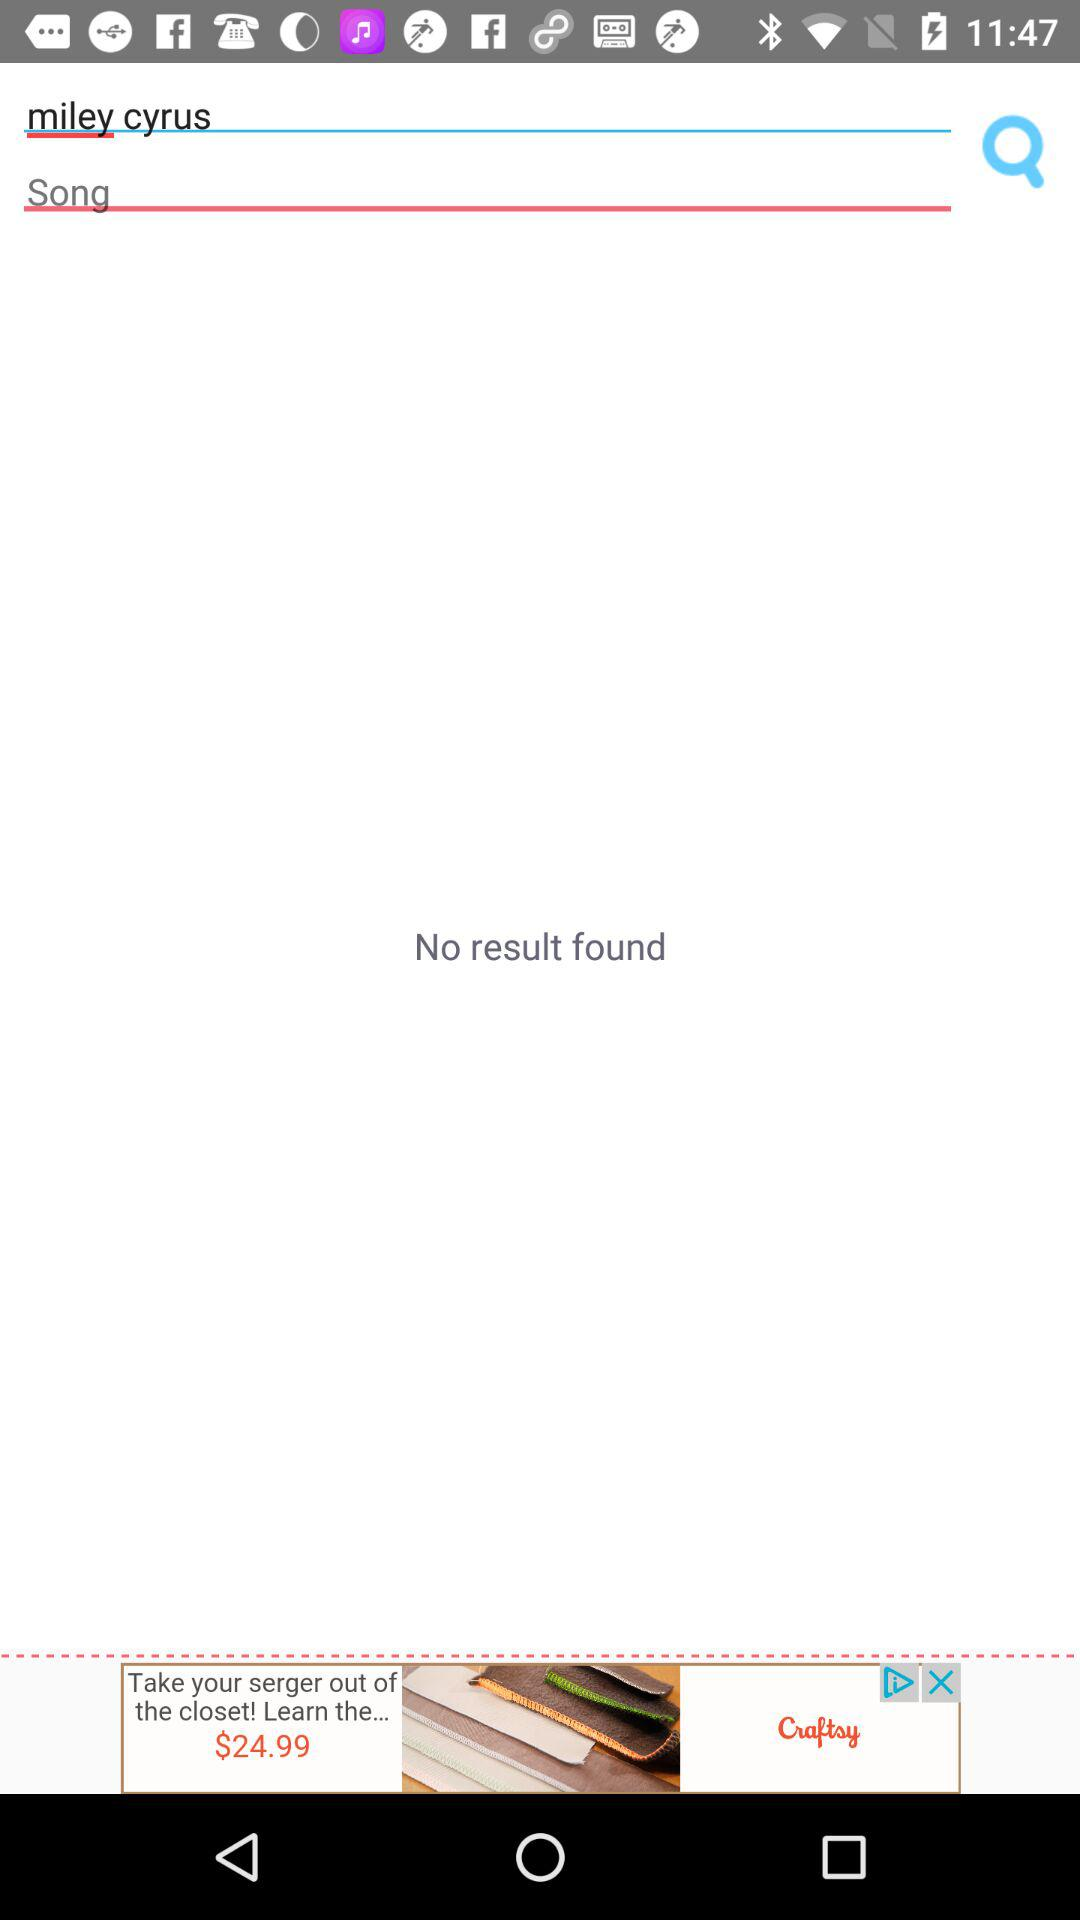What is the text entered in the search bar? The entered text is "miley cyrus". 